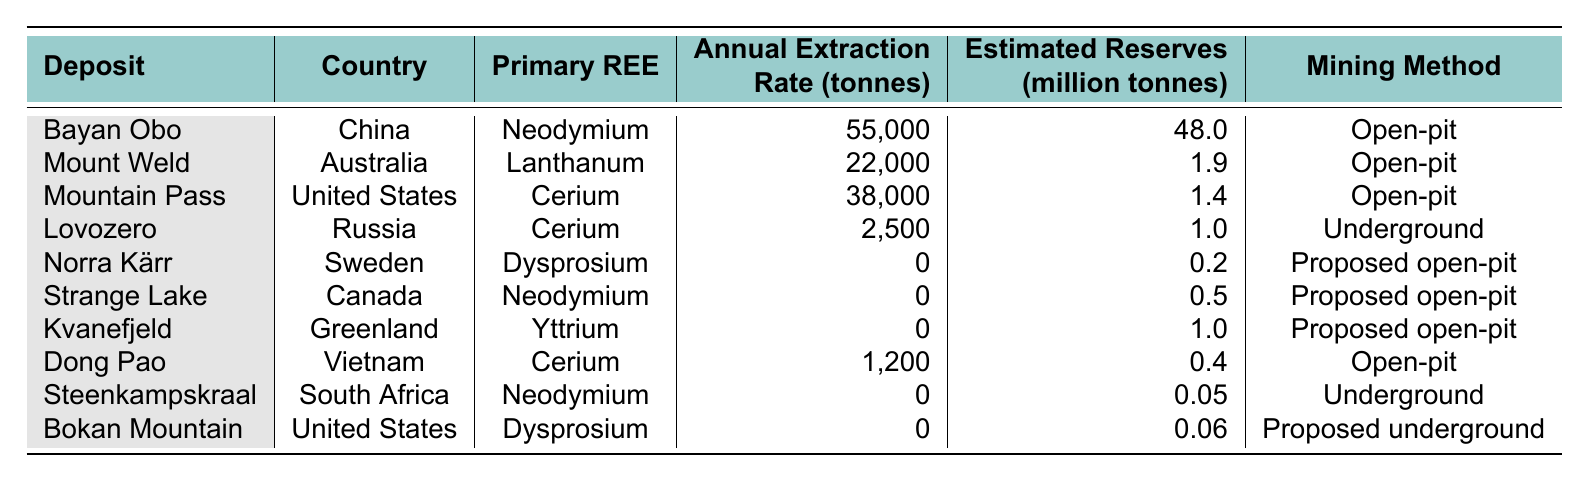What is the primary rare earth element extracted from Bayan Obo? The table lists Bayan Obo under the "Deposit" column, and the "Primary REE" column next to it shows that the primary rare earth element extracted is Neodymium.
Answer: Neodymium Which country has the highest annual extraction rate of rare earth elements? By examining the "Annual Extraction Rate (tonnes)" column, I see that Bayan Obo in China has the highest extraction rate at 55,000 tonnes.
Answer: China What mining method is used for the Mount Weld deposit? The table indicates that the mining method for Mount Weld is "Open-pit," as stated in the corresponding row in the "Mining Method" column.
Answer: Open-pit What is the ratio of estimated reserves to annual extraction rate for the Mountain Pass deposit? The estimated reserves for Mountain Pass are 1.4 million tonnes, and the annual extraction rate is 38,000 tonnes. The ratio is 1.4 million tonnes / 38,000 tonnes = 36.84 (rounded to two decimal places).
Answer: 36.84 Is there any rare earth element extraction reported for the Kvanefjeld deposit? In the "Annual Extraction Rate (tonnes)" column for Kvanefjeld, the value is 0, indicating that no extraction is currently reported.
Answer: No Which countries have deposits with zero annual extraction rates, and how many such countries are listed? By checking the "Annual Extraction Rate (tonnes)" column, I find that Norra Kärr, Strange Lake, Kvanefjeld, Steenkampskraal, and Bokan Mountain have zero extraction. This totals to five countries.
Answer: Five Determine the total annual extraction rate of all deposits listed in the table. Summing the "Annual Extraction Rate (tonnes)" for all deposits gives: 55,000 + 22,000 + 38,000 + 2,500 + 0 + 0 + 0 + 1,200 + 0 + 0 = 118,700 tonnes.
Answer: 118,700 tonnes Which primary rare earth element has the lowest annual extraction rate, and what is that rate? Upon reviewing, Lovozero in Russia has the lowest rate of 2,500 tonnes for the element Cerium.
Answer: Cerium, 2500 tonnes If the extraction methods required further classification, which method is used for the majority of deposits? Counting the methods, "Open-pit" is used for 6 out of the 10 deposits listed, which is the majority compared to the others.
Answer: Open-pit Are there any deposits where Dysprosium is extracted, and what is the extraction rate for those deposits? Considering the table, the deposits where Dysprosium is mentioned (Norra Kärr and Bokan Mountain) both report an extraction rate of 0 tonnes, indicating no current extraction.
Answer: No extraction currently 